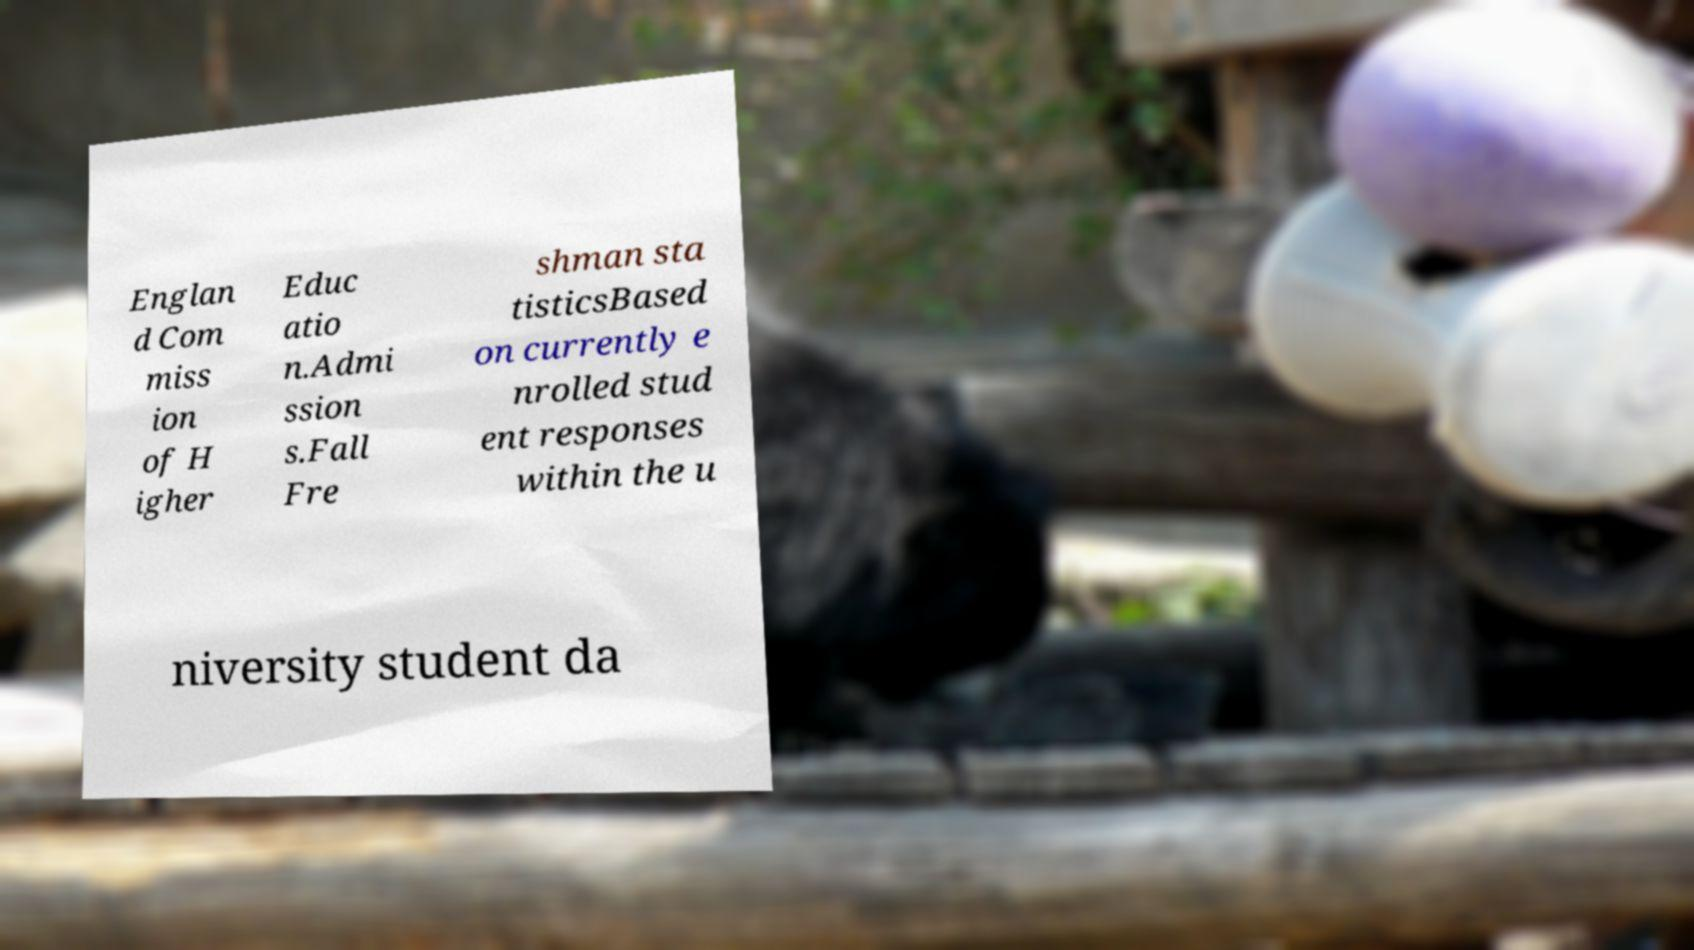For documentation purposes, I need the text within this image transcribed. Could you provide that? Englan d Com miss ion of H igher Educ atio n.Admi ssion s.Fall Fre shman sta tisticsBased on currently e nrolled stud ent responses within the u niversity student da 